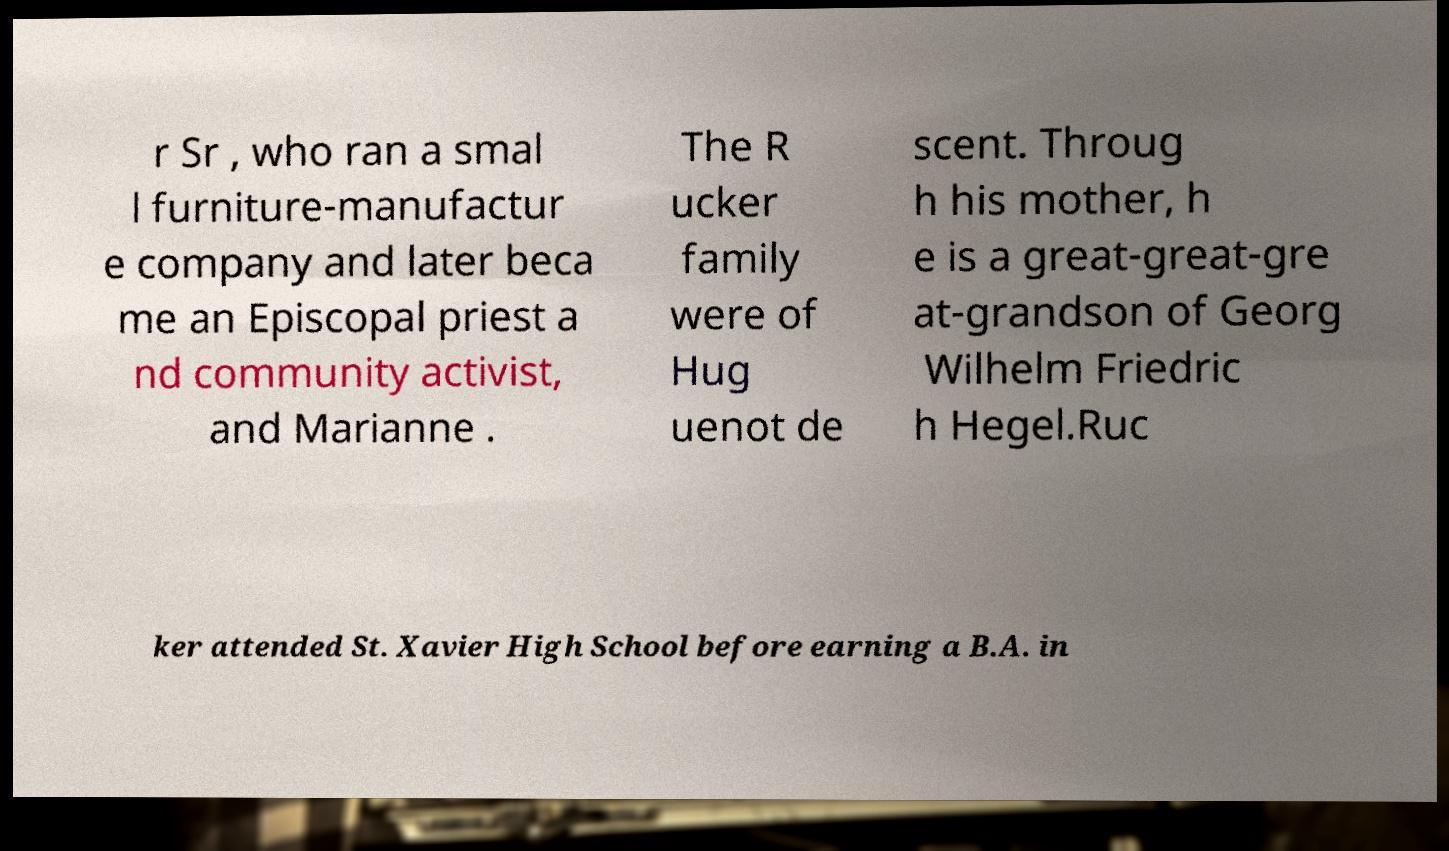Can you read and provide the text displayed in the image?This photo seems to have some interesting text. Can you extract and type it out for me? r Sr , who ran a smal l furniture-manufactur e company and later beca me an Episcopal priest a nd community activist, and Marianne . The R ucker family were of Hug uenot de scent. Throug h his mother, h e is a great-great-gre at-grandson of Georg Wilhelm Friedric h Hegel.Ruc ker attended St. Xavier High School before earning a B.A. in 